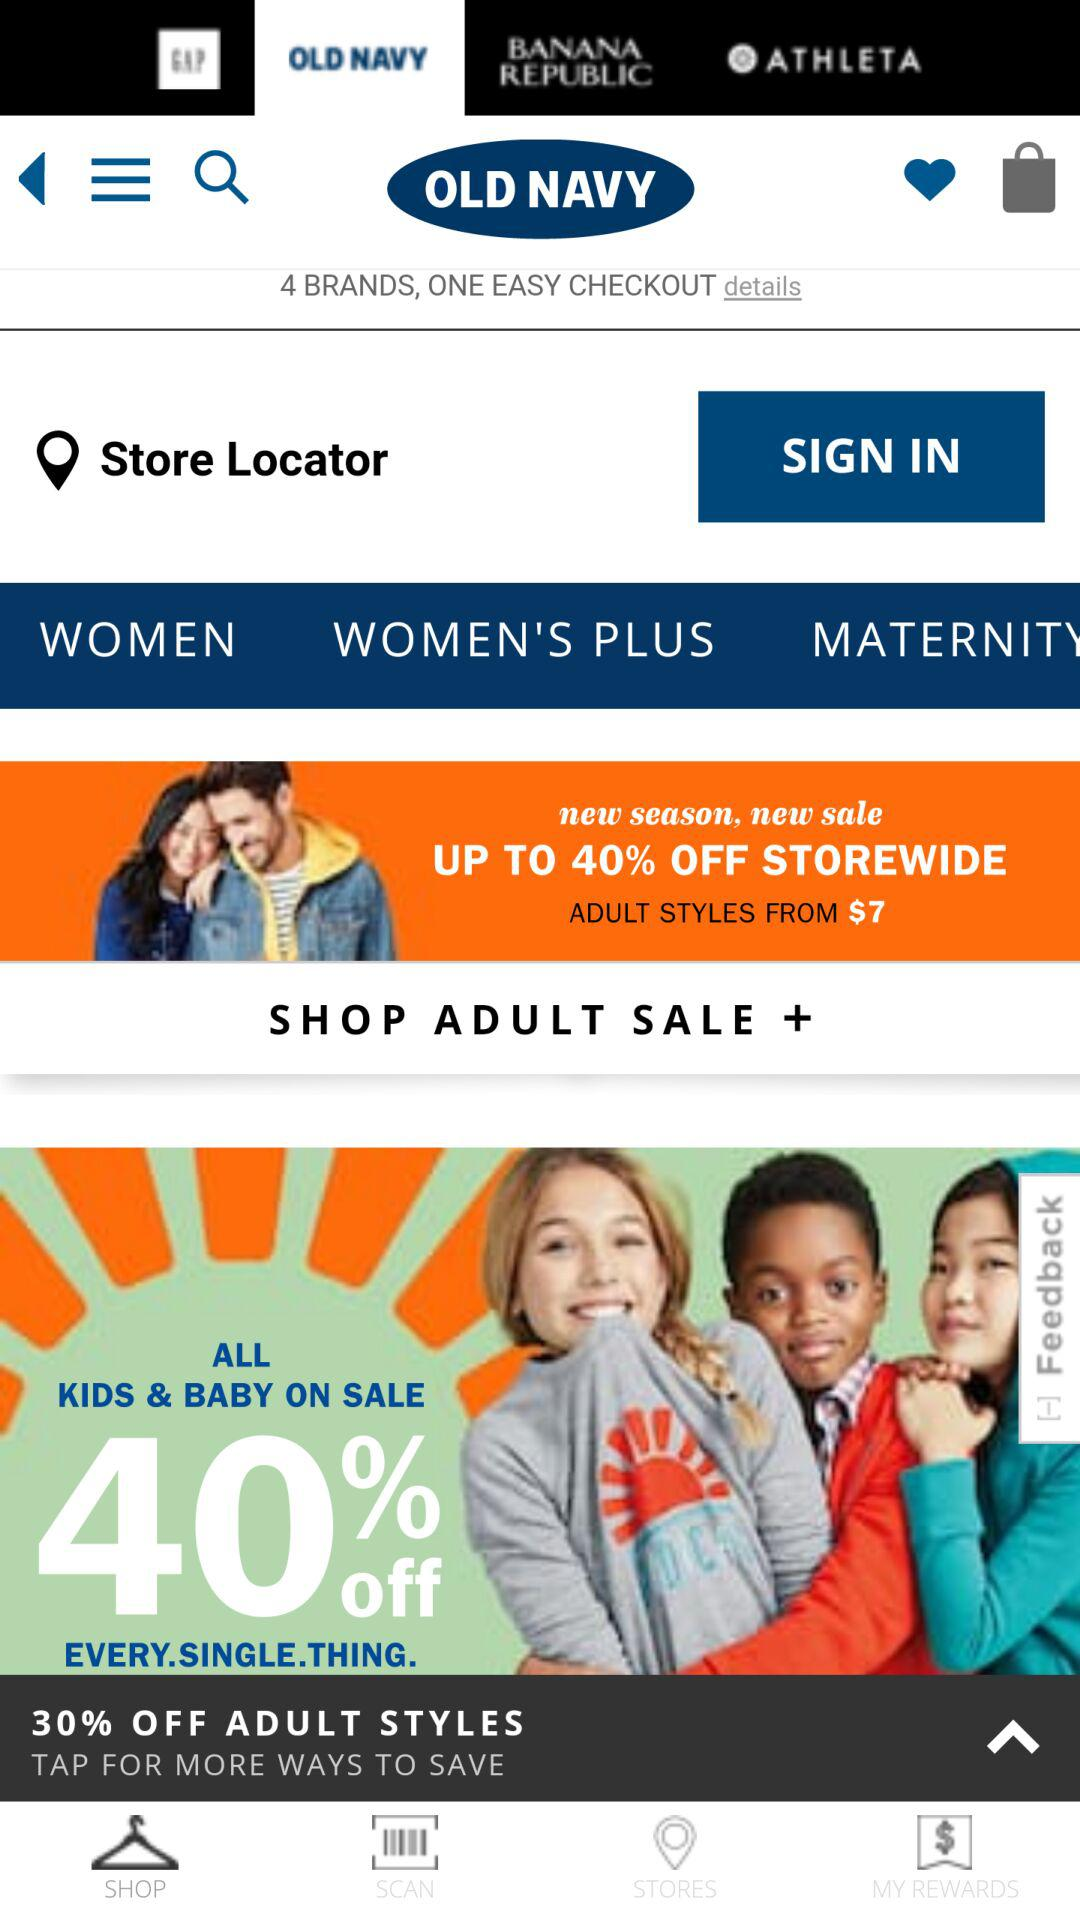How many brands can I shop from in one easy checkout?
Answer the question using a single word or phrase. 4 